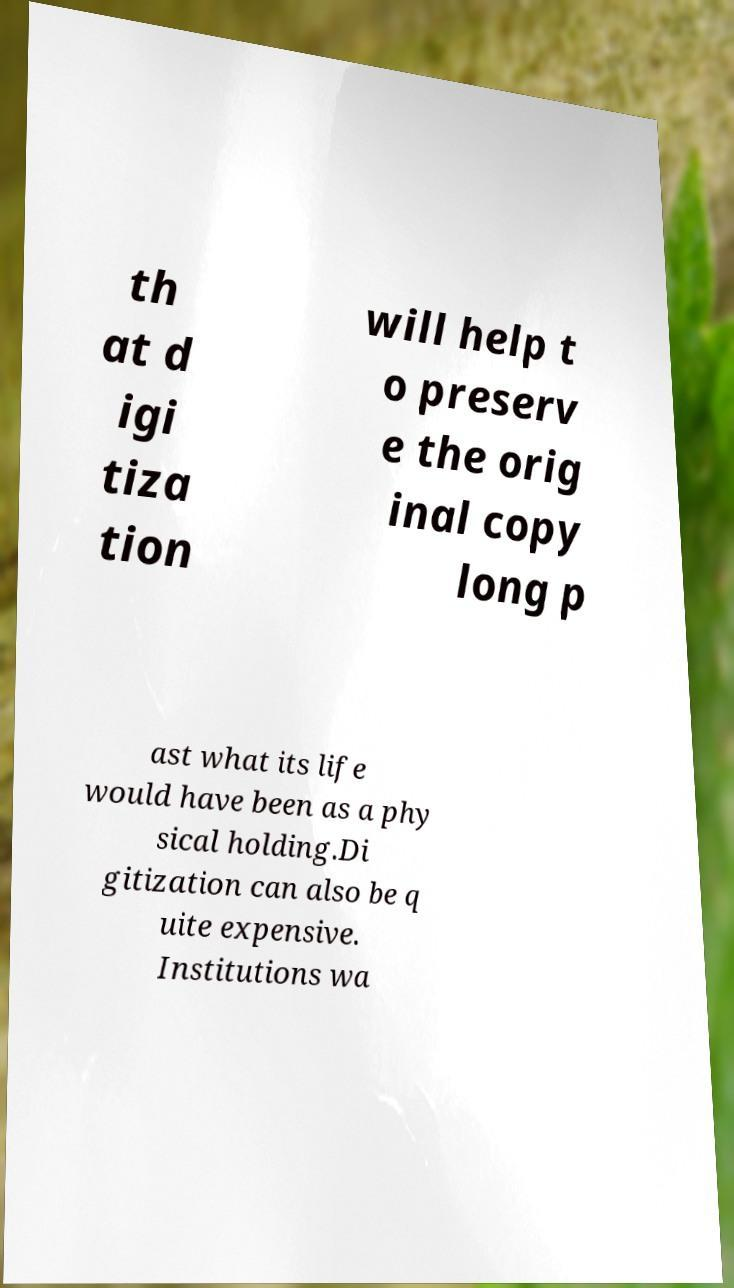There's text embedded in this image that I need extracted. Can you transcribe it verbatim? th at d igi tiza tion will help t o preserv e the orig inal copy long p ast what its life would have been as a phy sical holding.Di gitization can also be q uite expensive. Institutions wa 